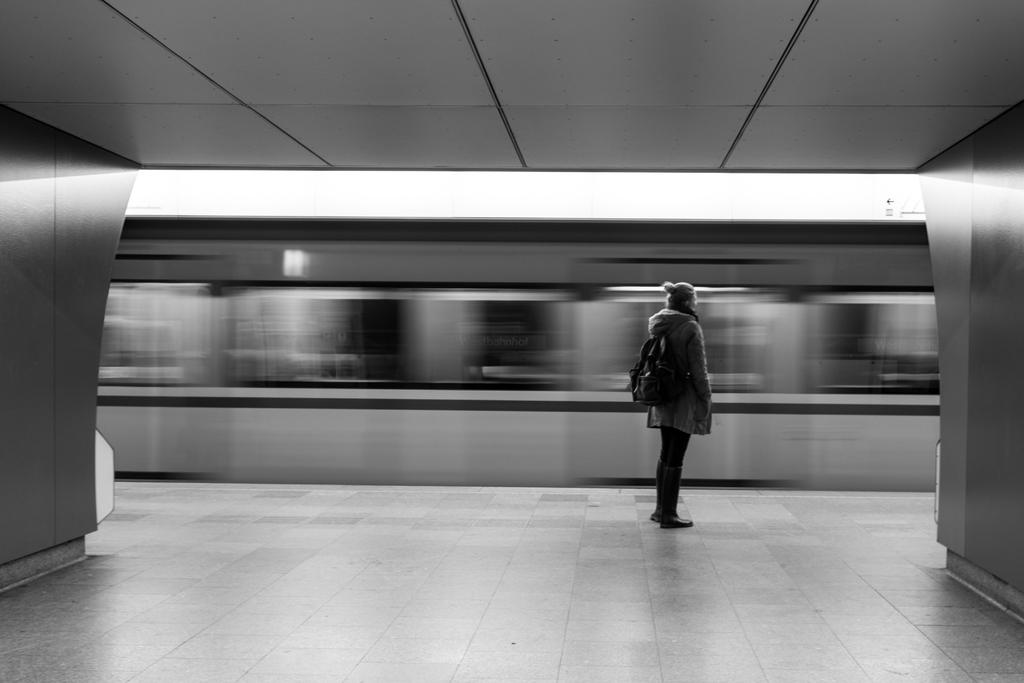What is the main subject of the image? There is a person standing in the center of the image. What is the person wearing in the image? The person is wearing a bag in the image. What color is the bag that the person is wearing? The bag is black in color. How would you describe the background of the image? The background of the image is blurry. What type of pie is the person holding in the image? There is no pie present in the image; the person is wearing a black bag. What type of suit is the person wearing in the image? There is no suit mentioned in the facts provided. The person is wearing a bag, and its color is black. 